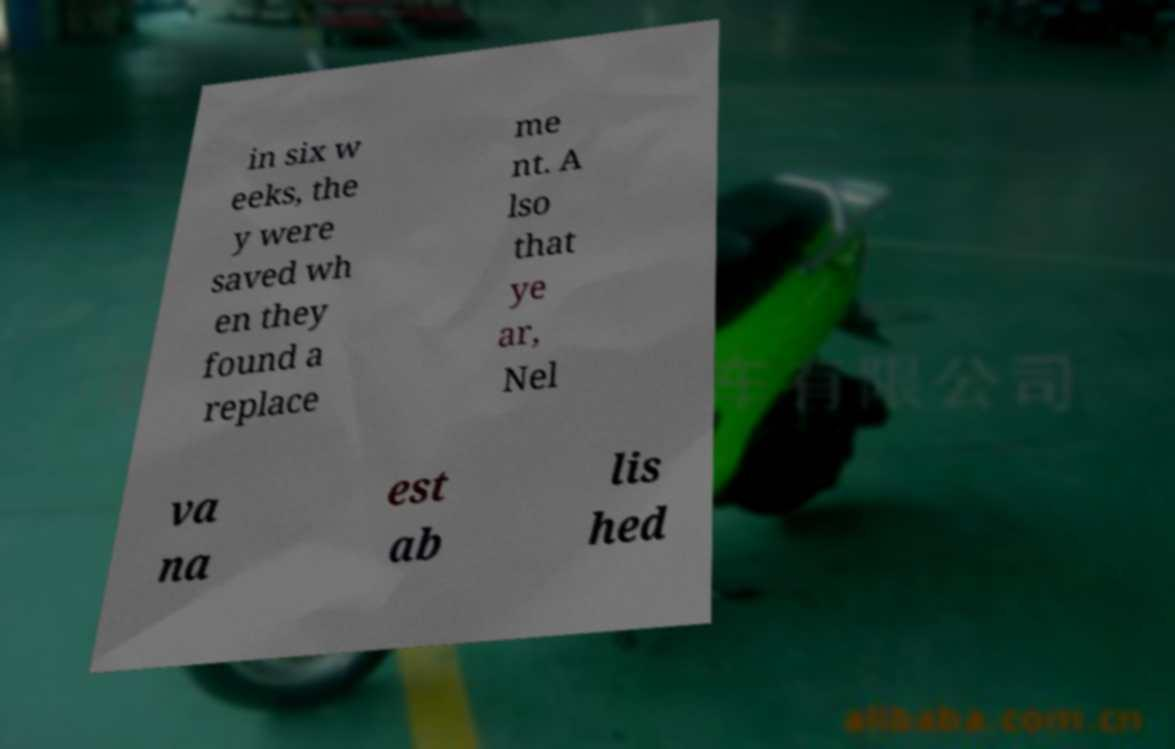Please read and relay the text visible in this image. What does it say? in six w eeks, the y were saved wh en they found a replace me nt. A lso that ye ar, Nel va na est ab lis hed 